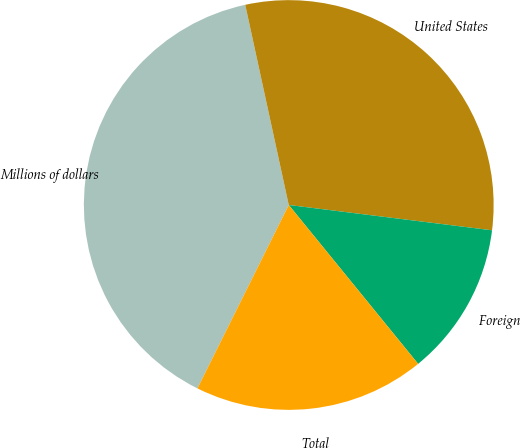<chart> <loc_0><loc_0><loc_500><loc_500><pie_chart><fcel>Millions of dollars<fcel>United States<fcel>Foreign<fcel>Total<nl><fcel>39.24%<fcel>30.38%<fcel>12.15%<fcel>18.23%<nl></chart> 